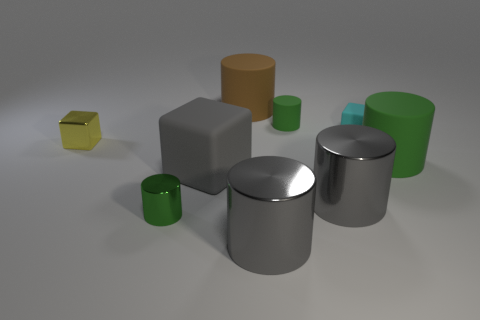Subtract all tiny yellow blocks. How many blocks are left? 2 Subtract all gray cylinders. How many cylinders are left? 4 Subtract all cylinders. How many objects are left? 3 Subtract 3 cylinders. How many cylinders are left? 3 Subtract all brown spheres. How many red blocks are left? 0 Add 3 gray metal cylinders. How many gray metal cylinders exist? 5 Subtract 0 red blocks. How many objects are left? 9 Subtract all cyan cylinders. Subtract all gray cubes. How many cylinders are left? 6 Subtract all large blocks. Subtract all small rubber objects. How many objects are left? 6 Add 5 green cylinders. How many green cylinders are left? 8 